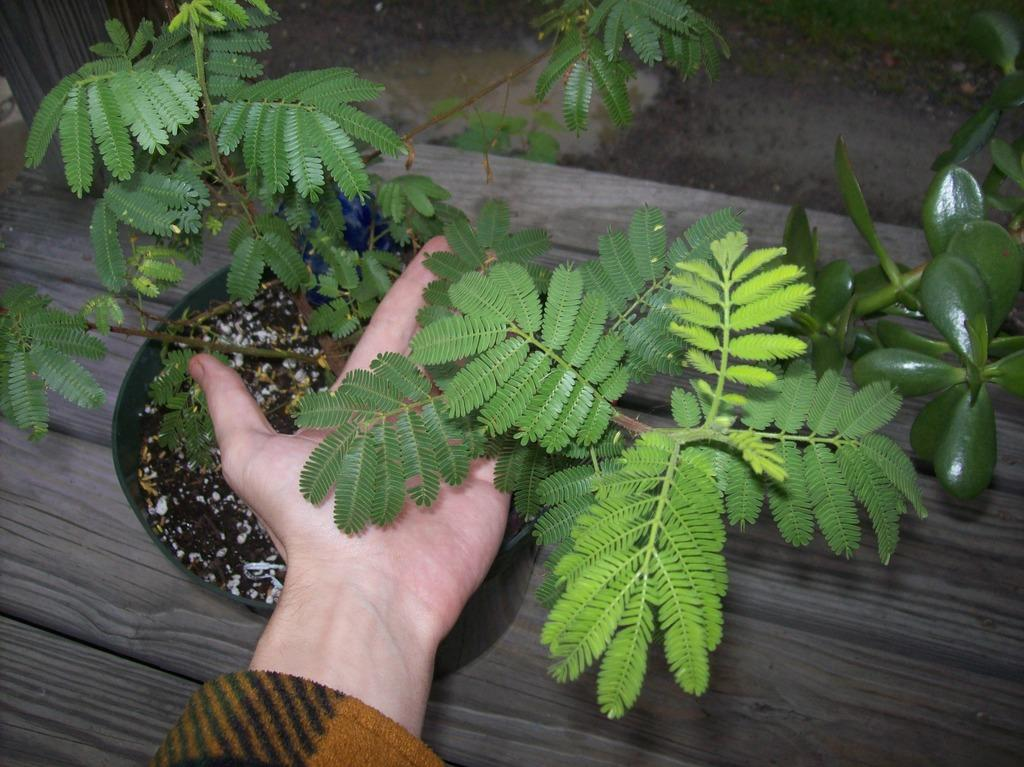What part of a person can be seen in the image? There is a person's hand in the image. What is the hand doing in the image? The hand is beneath the leaves of a plant. What type of container is holding the plant? There is a plant pot in the image. What material is the surface beneath the plant pot made of? The plant pot is placed on a wooden surface. How many oranges are being held by the pigs in the image? There are no pigs or oranges present in the image. 